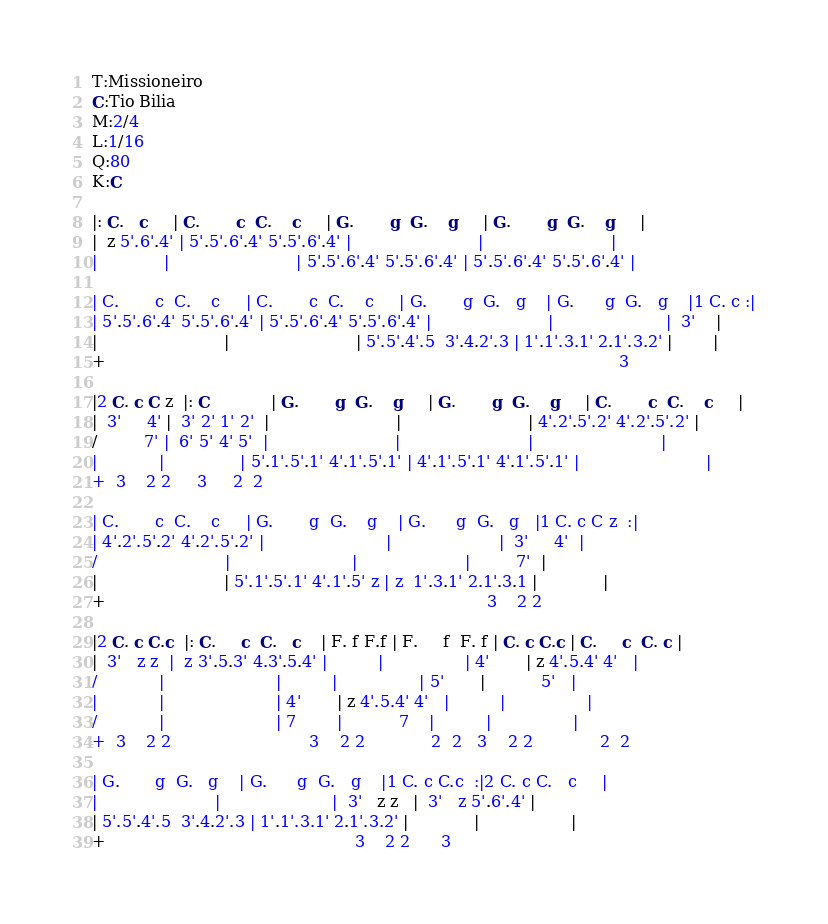<code> <loc_0><loc_0><loc_500><loc_500><_SQL_>T:Missioneiro
C:Tio Bilia
M:2/4
L:1/16
Q:80
K:C

|: C.   c     | C.       c  C.    c     | G.       g  G.    g     | G.       g  G.    g     |
|  z 5'.6'.4' | 5'.5'.6'.4' 5'.5'.6'.4' |                         |                         |
|             |                         | 5'.5'.6'.4' 5'.5'.6'.4' | 5'.5'.6'.4' 5'.5'.6'.4' |

| C.       c  C.    c     | C.       c  C.    c     | G.       g  G.   g    | G.      g  G.   g    |1 C. c :|
| 5'.5'.6'.4' 5'.5'.6'.4' | 5'.5'.6'.4' 5'.5'.6'.4' |                       |                      |  3'    |
|                         |                         | 5'.5'.4'.5  3'.4.2'.3 | 1'.1'.3.1' 2.1'.3.2' |        |
+                                                                                                     3

|2 C. c C z  |: C            | G.       g  G.    g     | G.       g  G.    g     | C.       c  C.    c     |
|  3'     4' |  3' 2' 1' 2'  |                         |                         | 4'.2'.5'.2' 4'.2'.5'.2' |
/         7' |  6' 5' 4' 5'  |                         |                         |                         |
|            |               | 5'.1'.5'.1' 4'.1'.5'.1' | 4'.1'.5'.1' 4'.1'.5'.1' |                         |
+  3    2 2     3     2  2

| C.       c  C.    c     | G.       g  G.    g    | G.      g  G.   g   |1 C. c C z  :|
| 4'.2'.5'.2' 4'.2'.5'.2' |                        |                     |  3'     4'  |
/                         |                        |                     |         7'  |
|                         | 5'.1'.5'.1' 4'.1'.5' z | z  1'.3.1' 2.1'.3.1 |             |
+                                                                           3    2 2

|2 C. c C.c  |: C.     c  C.   c    | F. f F.f | F.     f  F. f | C. c C.c | C.     c  C. c |
|  3'   z z  |  z 3'.5.3' 4.3'.5.4' |          |                | 4'       | z 4'.5.4' 4'   |
/            |                      |          |                | 5'       |           5'   |
|            |                      | 4'       | z 4'.5.4' 4'   |          |                |
/            |                      | 7        |           7    |          |                |
+  3    2 2                           3    2 2             2  2   3    2 2             2  2

| G.       g  G.   g    | G.      g  G.   g    |1 C. c C.c  :|2 C. c C.   c     |
|                       |                      |  3'   z z   |  3'   z 5'.6'.4' |
| 5'.5'.4'.5  3'.4.2'.3 | 1'.1'.3.1' 2.1'.3.2' |             |                  |
+                                                 3    2 2      3
</code> 